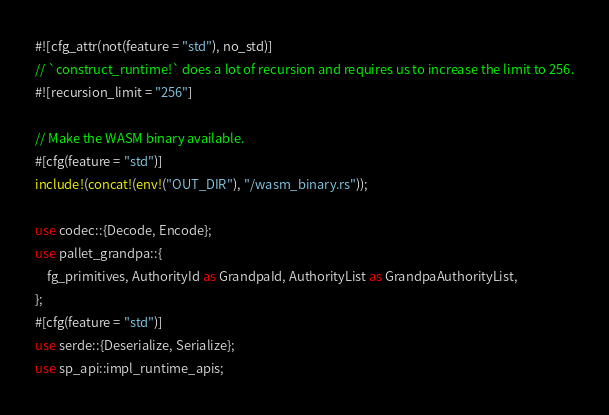Convert code to text. <code><loc_0><loc_0><loc_500><loc_500><_Rust_>#![cfg_attr(not(feature = "std"), no_std)]
// `construct_runtime!` does a lot of recursion and requires us to increase the limit to 256.
#![recursion_limit = "256"]

// Make the WASM binary available.
#[cfg(feature = "std")]
include!(concat!(env!("OUT_DIR"), "/wasm_binary.rs"));

use codec::{Decode, Encode};
use pallet_grandpa::{
	fg_primitives, AuthorityId as GrandpaId, AuthorityList as GrandpaAuthorityList,
};
#[cfg(feature = "std")]
use serde::{Deserialize, Serialize};
use sp_api::impl_runtime_apis;</code> 